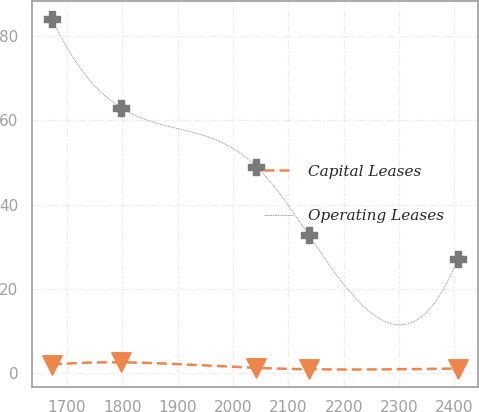<chart> <loc_0><loc_0><loc_500><loc_500><line_chart><ecel><fcel>Capital Leases<fcel>Operating Leases<nl><fcel>1673.19<fcel>2.01<fcel>84.17<nl><fcel>1798.72<fcel>2.55<fcel>62.94<nl><fcel>2042.19<fcel>1.24<fcel>49.06<nl><fcel>2136.86<fcel>0.92<fcel>32.78<nl><fcel>2405.84<fcel>1.08<fcel>27.07<nl></chart> 